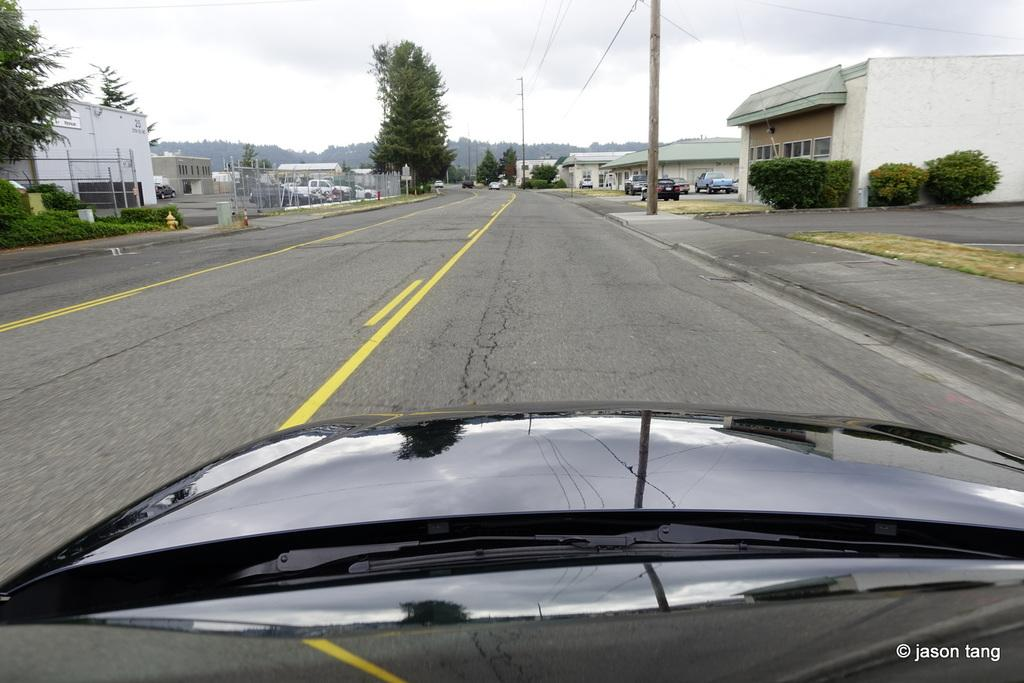What type of vehicle is at the bottom of the image? There is a black color car at the bottom of the image. What can be seen in the background of the image? There are trees in the background of the image. What structures are present in the image? There are electric poles and houses in the image. What is the primary mode of transportation in the image? There is a road in the image, which suggests that cars or other vehicles are used for transportation. How many clocks can be seen in the image? There are no clocks visible in the image. What type of market is present in the image? There is no market present in the image. 